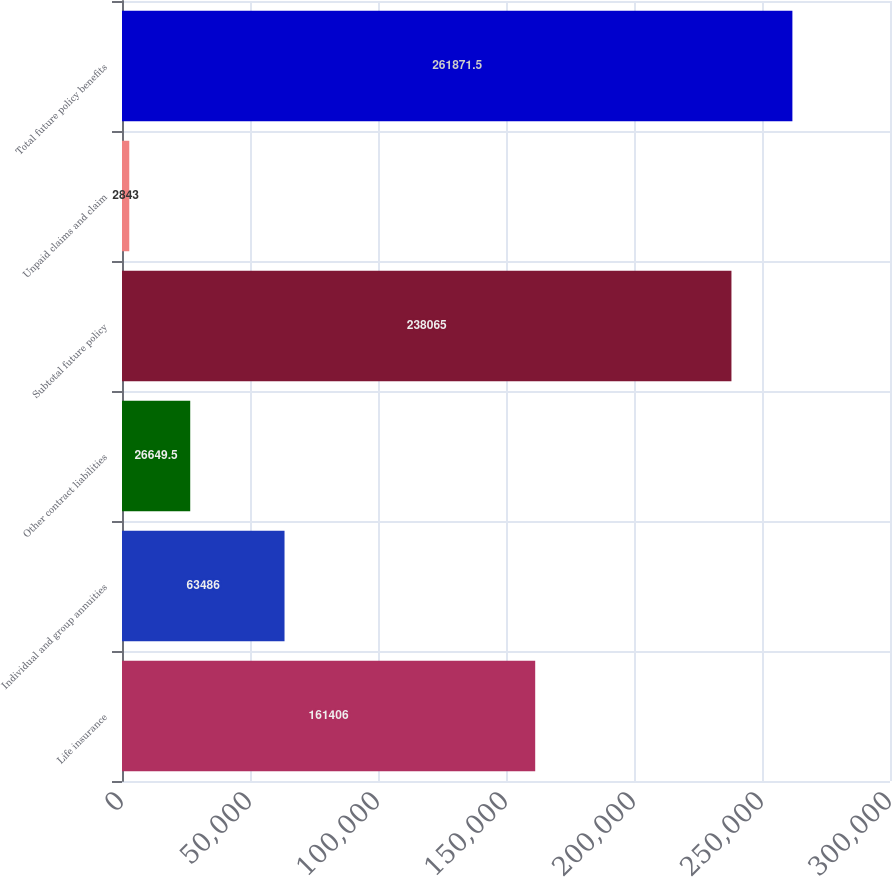<chart> <loc_0><loc_0><loc_500><loc_500><bar_chart><fcel>Life insurance<fcel>Individual and group annuities<fcel>Other contract liabilities<fcel>Subtotal future policy<fcel>Unpaid claims and claim<fcel>Total future policy benefits<nl><fcel>161406<fcel>63486<fcel>26649.5<fcel>238065<fcel>2843<fcel>261872<nl></chart> 